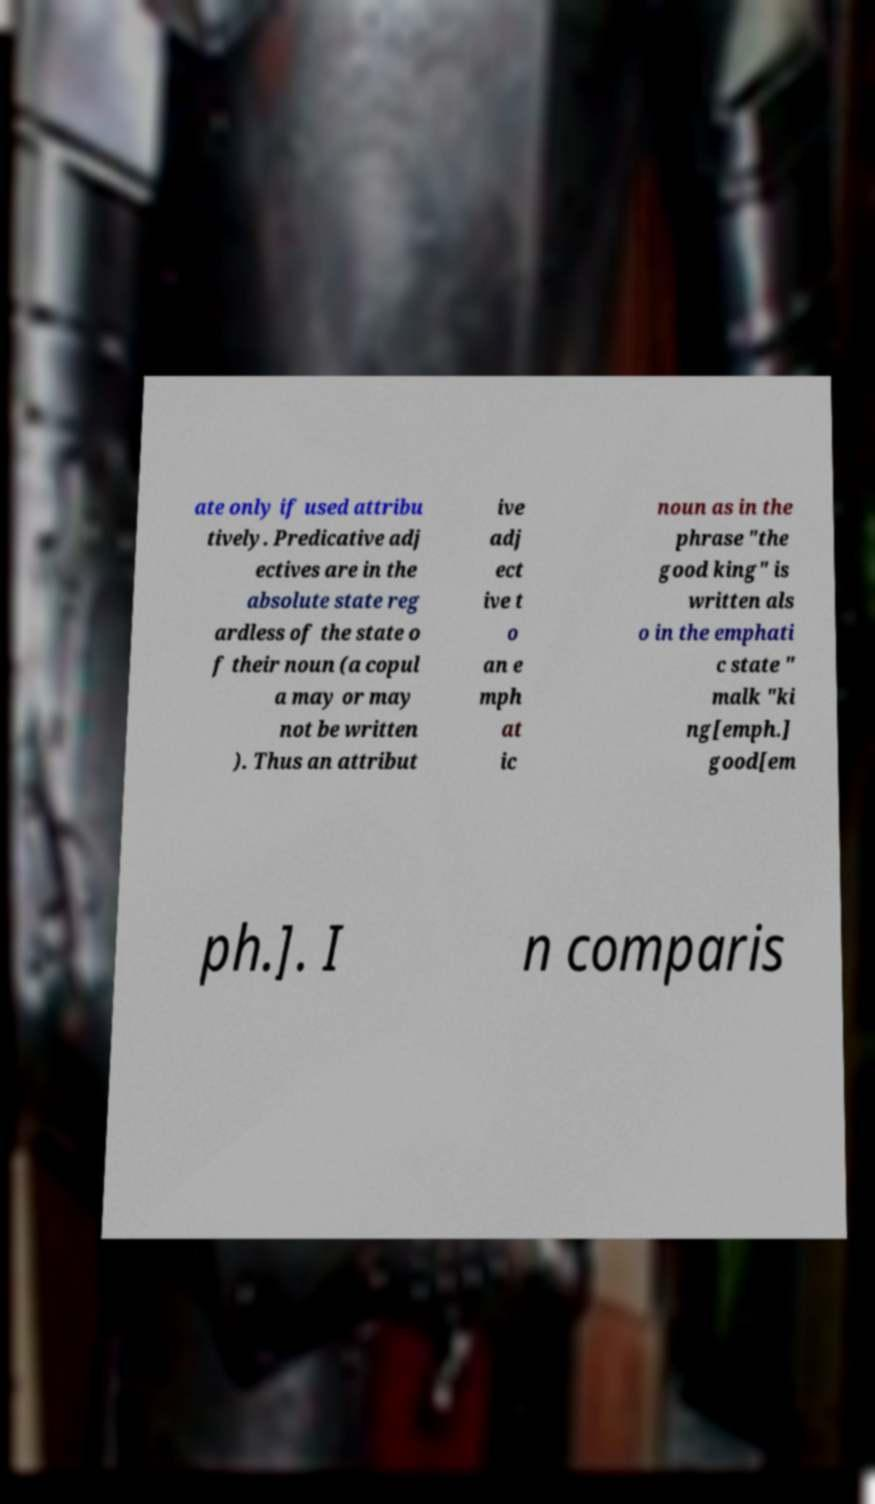Please identify and transcribe the text found in this image. ate only if used attribu tively. Predicative adj ectives are in the absolute state reg ardless of the state o f their noun (a copul a may or may not be written ). Thus an attribut ive adj ect ive t o an e mph at ic noun as in the phrase "the good king" is written als o in the emphati c state " malk "ki ng[emph.] good[em ph.]. I n comparis 